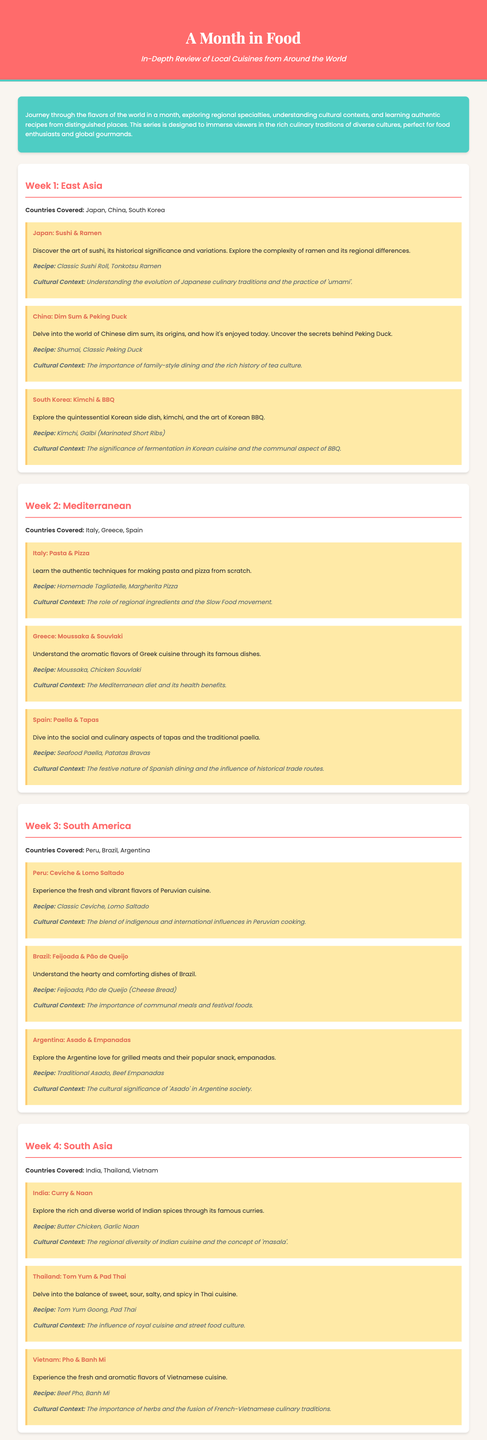What countries are covered in Week 1? Week 1 focuses on East Asia, covering Japan, China, and South Korea.
Answer: Japan, China, South Korea What is the recipe associated with the dish Moussaka? The recipe provided for Moussaka is mentioned in Week 2 under Greece.
Answer: Moussaka What is the cultural context for South Korea? The cultural context discusses the significance of fermentation and communal BBQ, explored in Week 1.
Answer: Fermentation and communal BBQ How many weeks are in the syllabus? The syllabus outlines content for four distinct weeks, each focusing on different regions.
Answer: 4 What type of cuisine is explored in Week 3? Week 3 focuses on the cuisines of South America, specifically from countries like Peru, Brazil, and Argentina.
Answer: South America What dish is highlighted in Japan's section? The highlighted dishes in Japan include sushi and ramen, as detailed in the Week 1 section.
Answer: Sushi & Ramen What is the recipe for the Brazilian dish mentioned? The Brazilian dish mentioned is Feijoada, which is covered in Week 3.
Answer: Feijoada How does the syllabus describe the role of regional ingredients in Italian cuisine? The syllabus explains this in the context of Italian cuisine under Week 2, indicating the importance of these ingredients.
Answer: Regional ingredients What is the focus of the cultural context for Thailand? It discusses the influence of royal cuisine and street food culture, as outlined in Week 4.
Answer: Royal cuisine and street food culture 